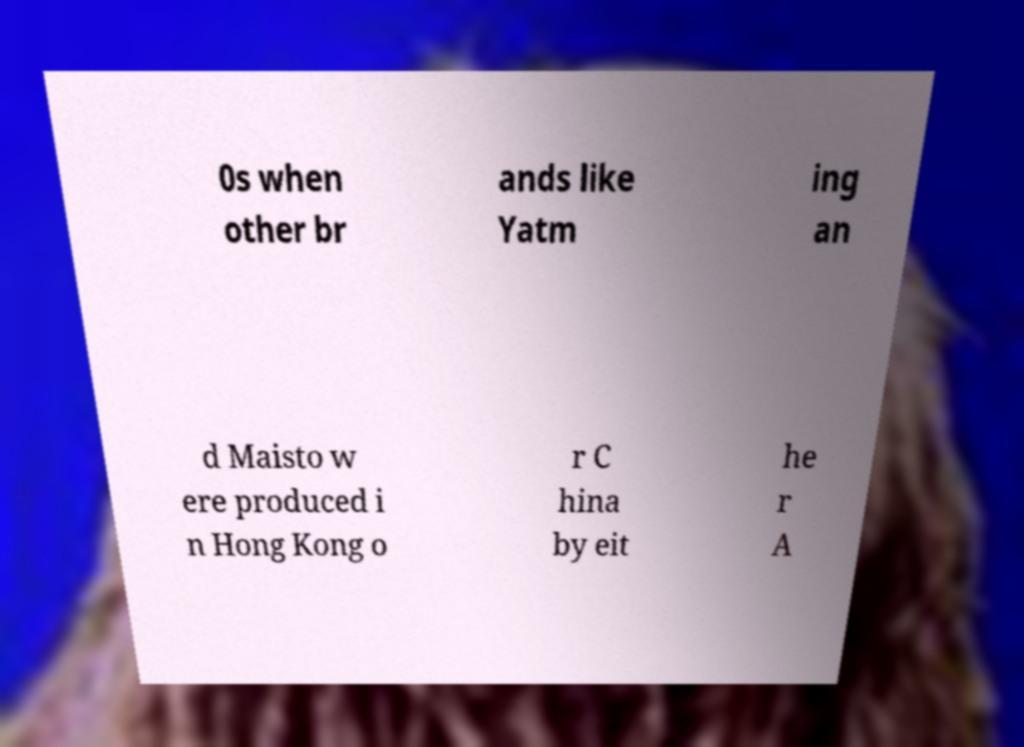Can you read and provide the text displayed in the image?This photo seems to have some interesting text. Can you extract and type it out for me? 0s when other br ands like Yatm ing an d Maisto w ere produced i n Hong Kong o r C hina by eit he r A 